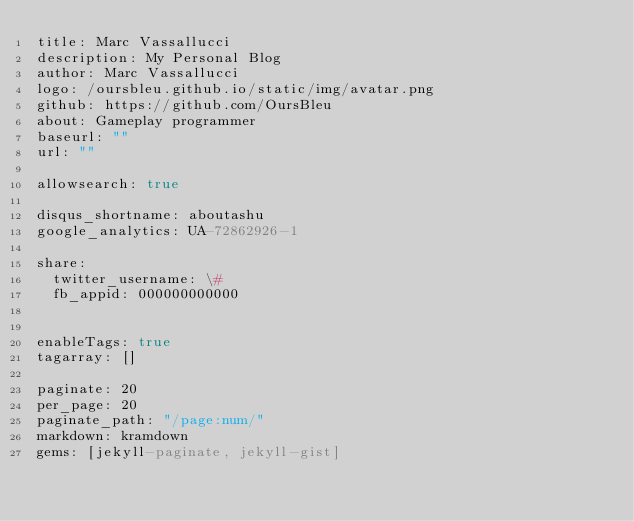<code> <loc_0><loc_0><loc_500><loc_500><_YAML_>title: Marc Vassallucci
description: My Personal Blog
author: Marc Vassallucci
logo: /oursbleu.github.io/static/img/avatar.png
github: https://github.com/OursBleu
about: Gameplay programmer
baseurl: ""
url: ""

allowsearch: true

disqus_shortname: aboutashu
google_analytics: UA-72862926-1

share:
  twitter_username: \#
  fb_appid: 000000000000


enableTags: true
tagarray: []

paginate: 20
per_page: 20
paginate_path: "/page:num/"
markdown: kramdown
gems: [jekyll-paginate, jekyll-gist]
</code> 